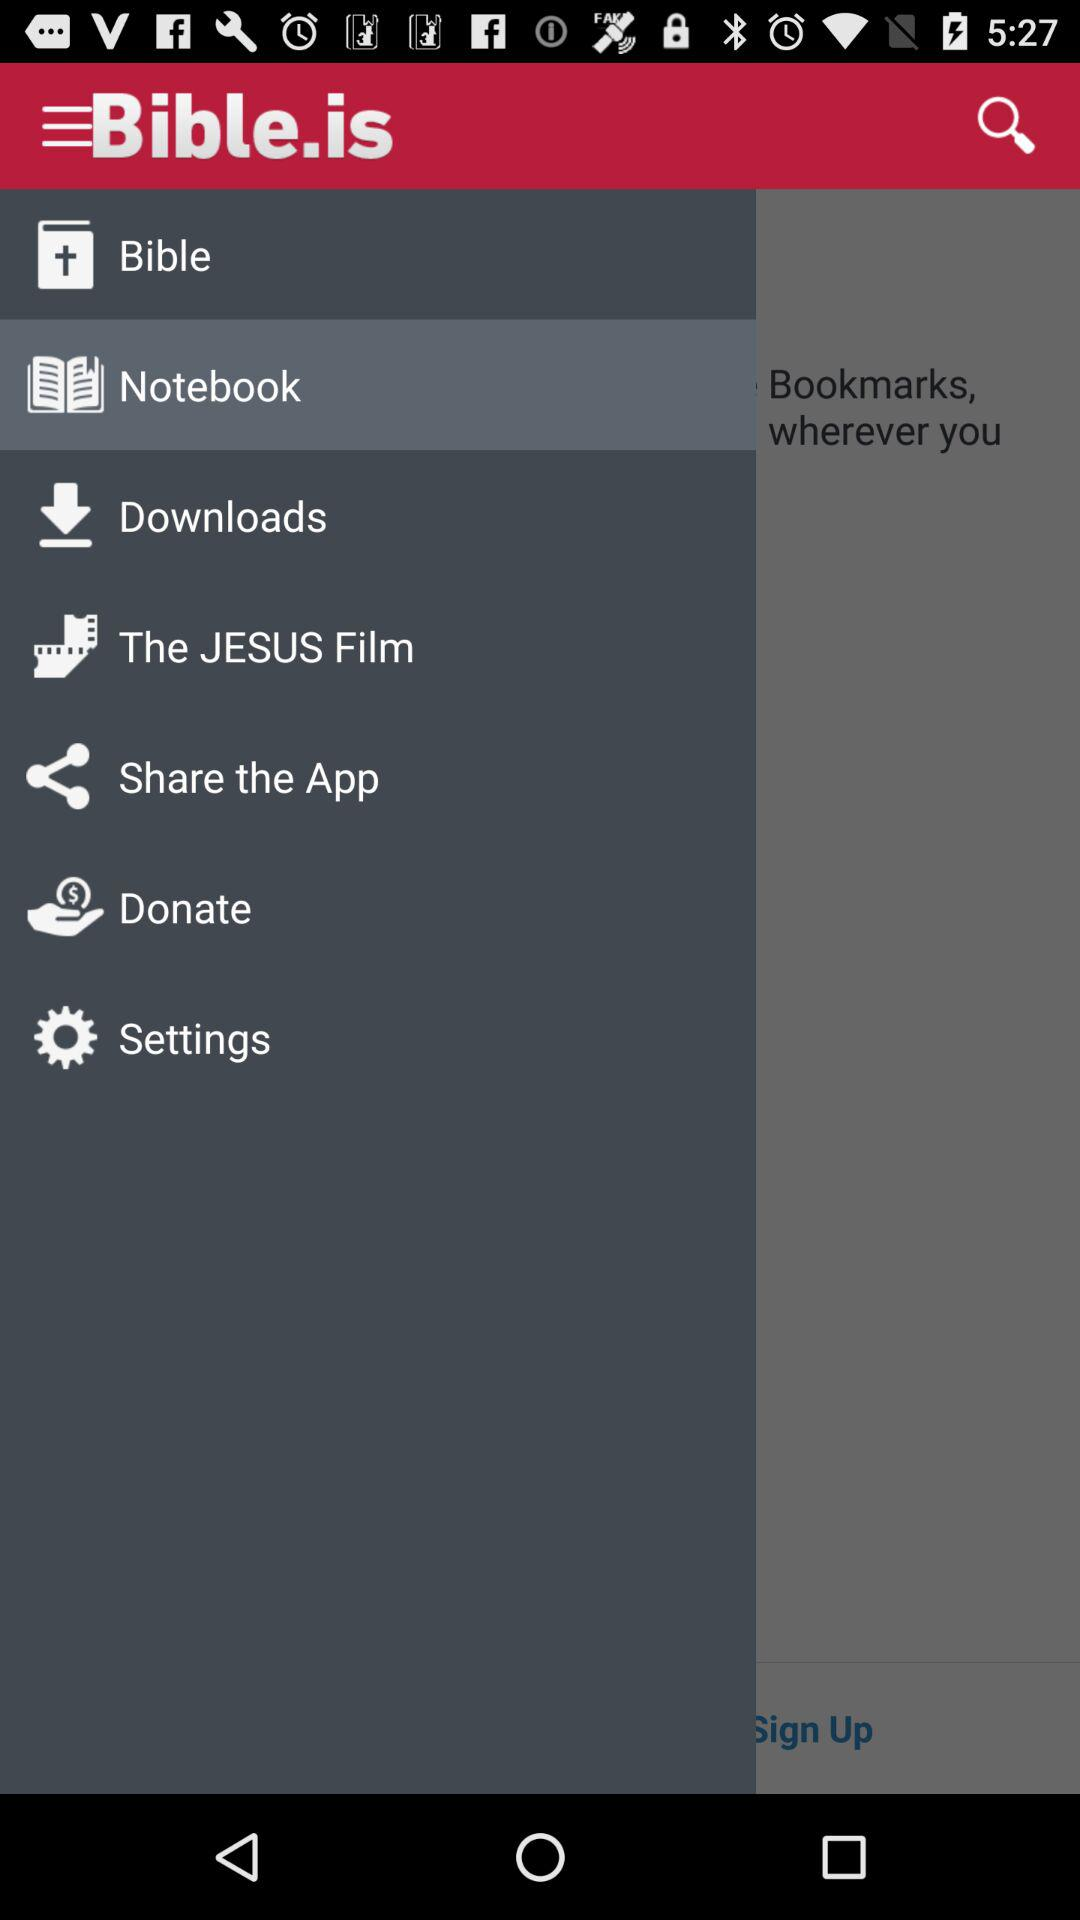How many items have a text label?
Answer the question using a single word or phrase. 7 